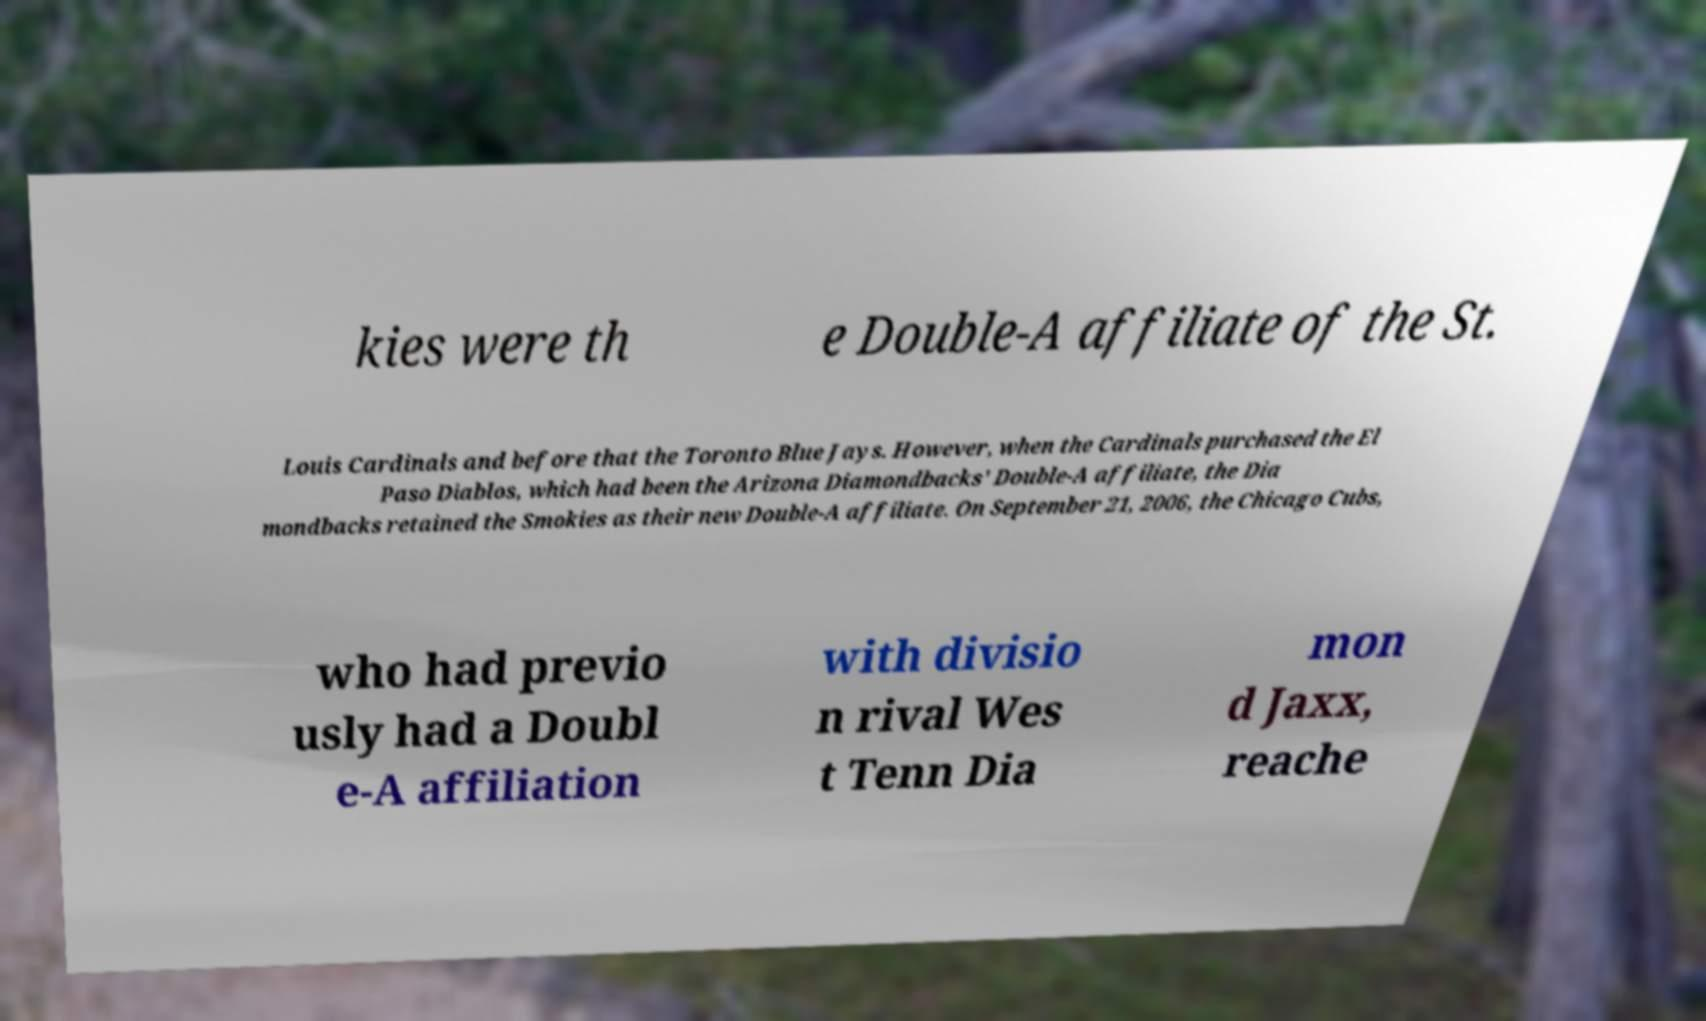There's text embedded in this image that I need extracted. Can you transcribe it verbatim? kies were th e Double-A affiliate of the St. Louis Cardinals and before that the Toronto Blue Jays. However, when the Cardinals purchased the El Paso Diablos, which had been the Arizona Diamondbacks' Double-A affiliate, the Dia mondbacks retained the Smokies as their new Double-A affiliate. On September 21, 2006, the Chicago Cubs, who had previo usly had a Doubl e-A affiliation with divisio n rival Wes t Tenn Dia mon d Jaxx, reache 